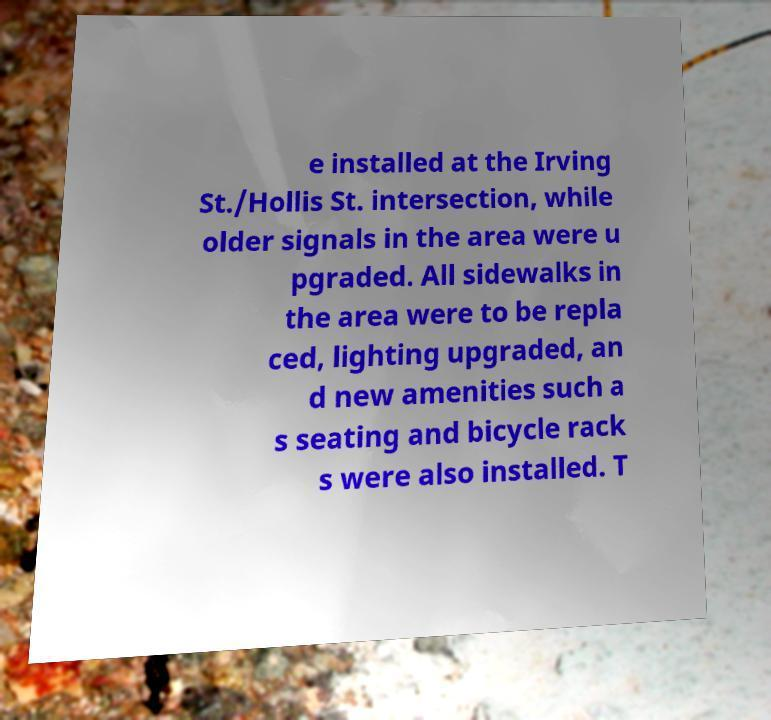Could you assist in decoding the text presented in this image and type it out clearly? e installed at the Irving St./Hollis St. intersection, while older signals in the area were u pgraded. All sidewalks in the area were to be repla ced, lighting upgraded, an d new amenities such a s seating and bicycle rack s were also installed. T 